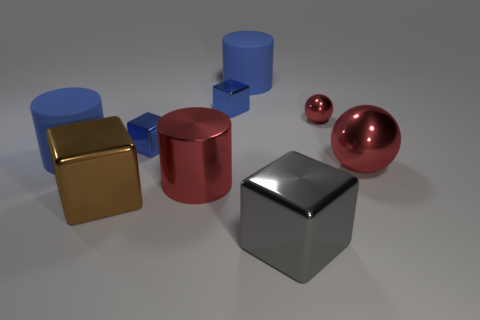There is a big metal thing that is both on the right side of the red shiny cylinder and on the left side of the small red metal thing; what color is it?
Make the answer very short. Gray. There is a large block that is behind the big gray metallic block; what number of large red metal objects are in front of it?
Offer a very short reply. 0. There is a brown object that is the same shape as the large gray shiny object; what is it made of?
Make the answer very short. Metal. What is the color of the large sphere?
Give a very brief answer. Red. What number of things are rubber things or small cyan cylinders?
Your response must be concise. 2. What is the shape of the metallic object that is behind the tiny object that is to the right of the big gray shiny thing?
Offer a very short reply. Cube. What number of other things are made of the same material as the large gray thing?
Give a very brief answer. 6. Is the big red sphere made of the same material as the large blue cylinder that is on the left side of the brown thing?
Give a very brief answer. No. What number of objects are either objects right of the gray shiny object or large cylinders left of the brown block?
Your answer should be compact. 3. What number of other things are there of the same color as the metal cylinder?
Ensure brevity in your answer.  2. 